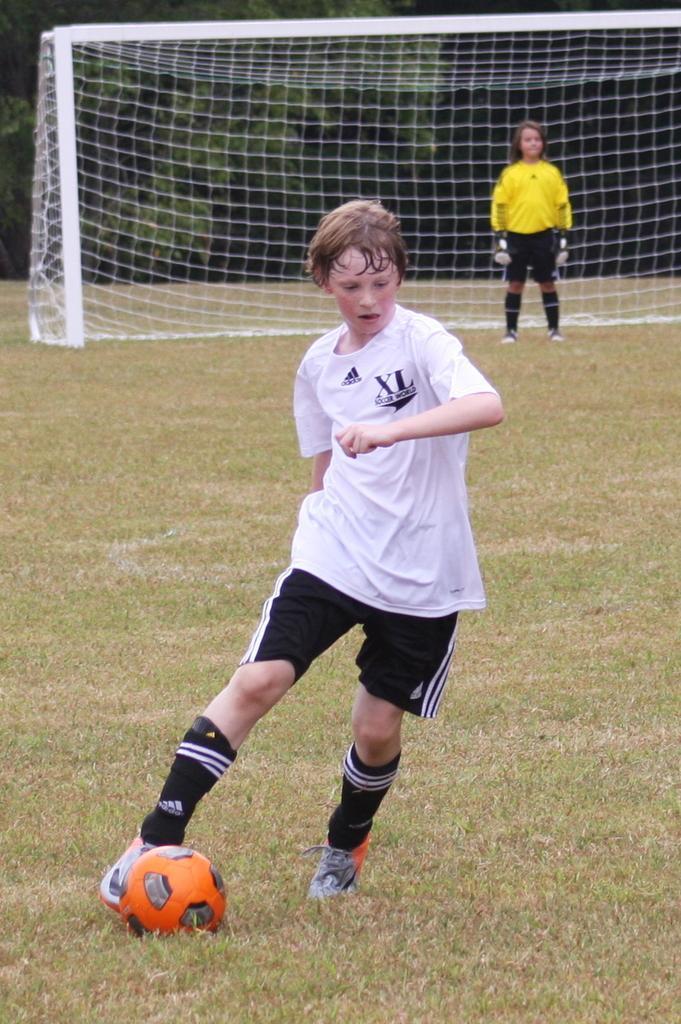How would you summarize this image in a sentence or two? As we can see in the image there are trees, fence, two people over here. The man who is over here is wearing white color t shirt and hitting a orange color bold and the woman who is standing over here is wearing yellow color t shirt. 